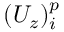Convert formula to latex. <formula><loc_0><loc_0><loc_500><loc_500>( U _ { z } ) _ { i } ^ { p }</formula> 